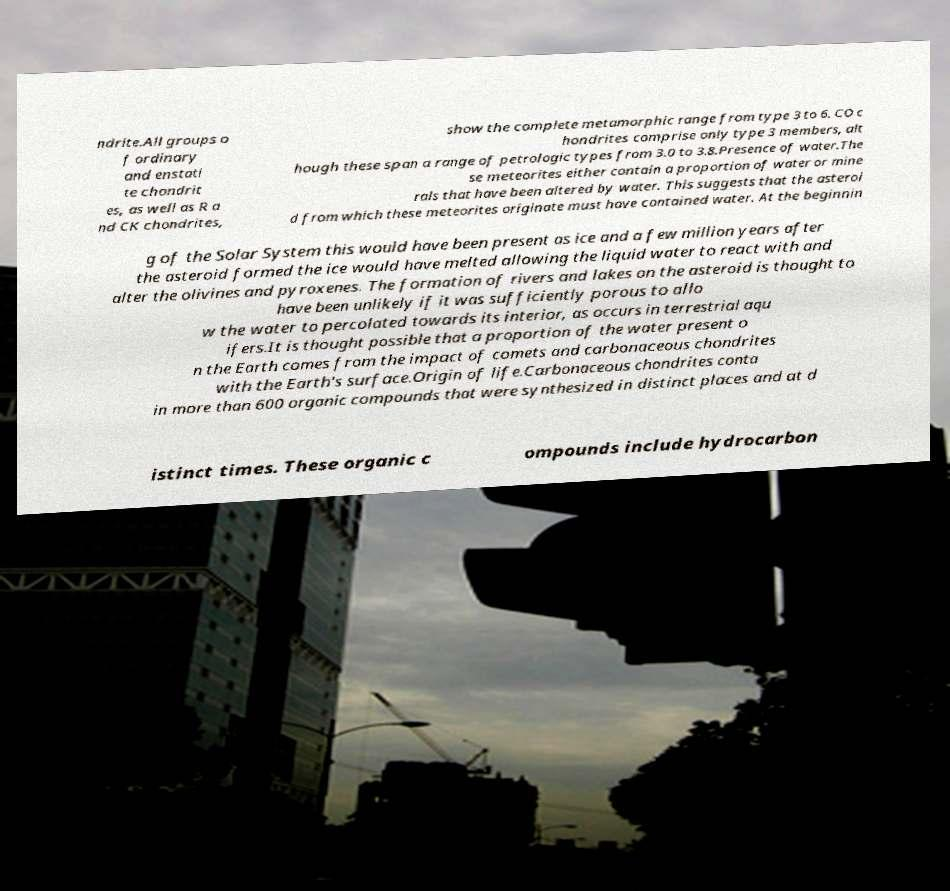For documentation purposes, I need the text within this image transcribed. Could you provide that? ndrite.All groups o f ordinary and enstati te chondrit es, as well as R a nd CK chondrites, show the complete metamorphic range from type 3 to 6. CO c hondrites comprise only type 3 members, alt hough these span a range of petrologic types from 3.0 to 3.8.Presence of water.The se meteorites either contain a proportion of water or mine rals that have been altered by water. This suggests that the asteroi d from which these meteorites originate must have contained water. At the beginnin g of the Solar System this would have been present as ice and a few million years after the asteroid formed the ice would have melted allowing the liquid water to react with and alter the olivines and pyroxenes. The formation of rivers and lakes on the asteroid is thought to have been unlikely if it was sufficiently porous to allo w the water to percolated towards its interior, as occurs in terrestrial aqu ifers.It is thought possible that a proportion of the water present o n the Earth comes from the impact of comets and carbonaceous chondrites with the Earth's surface.Origin of life.Carbonaceous chondrites conta in more than 600 organic compounds that were synthesized in distinct places and at d istinct times. These organic c ompounds include hydrocarbon 